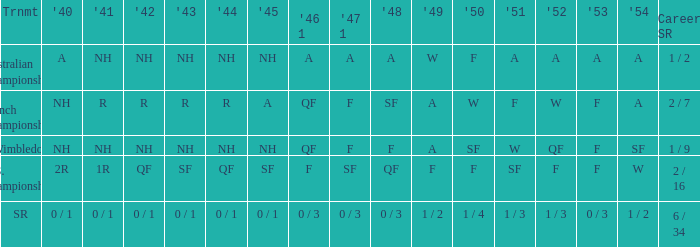What is the 1944 result for the U.S. Championships? QF. 